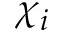Convert formula to latex. <formula><loc_0><loc_0><loc_500><loc_500>\chi _ { i }</formula> 